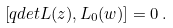<formula> <loc_0><loc_0><loc_500><loc_500>\left [ q d e t L ( z ) , L _ { 0 } ( w ) \right ] = 0 \, .</formula> 